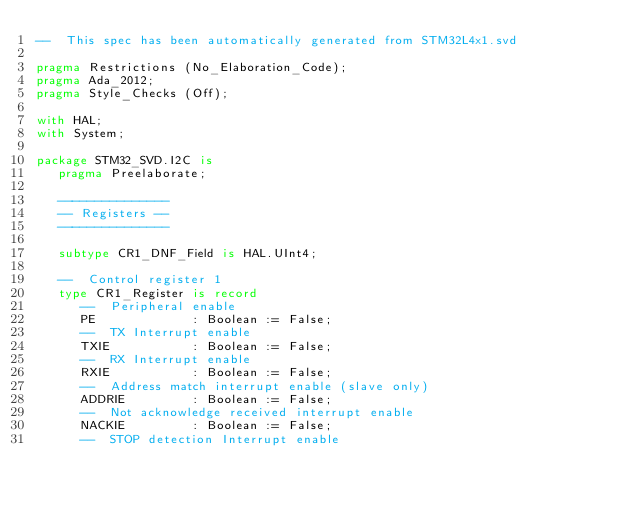Convert code to text. <code><loc_0><loc_0><loc_500><loc_500><_Ada_>--  This spec has been automatically generated from STM32L4x1.svd

pragma Restrictions (No_Elaboration_Code);
pragma Ada_2012;
pragma Style_Checks (Off);

with HAL;
with System;

package STM32_SVD.I2C is
   pragma Preelaborate;

   ---------------
   -- Registers --
   ---------------

   subtype CR1_DNF_Field is HAL.UInt4;

   --  Control register 1
   type CR1_Register is record
      --  Peripheral enable
      PE             : Boolean := False;
      --  TX Interrupt enable
      TXIE           : Boolean := False;
      --  RX Interrupt enable
      RXIE           : Boolean := False;
      --  Address match interrupt enable (slave only)
      ADDRIE         : Boolean := False;
      --  Not acknowledge received interrupt enable
      NACKIE         : Boolean := False;
      --  STOP detection Interrupt enable</code> 